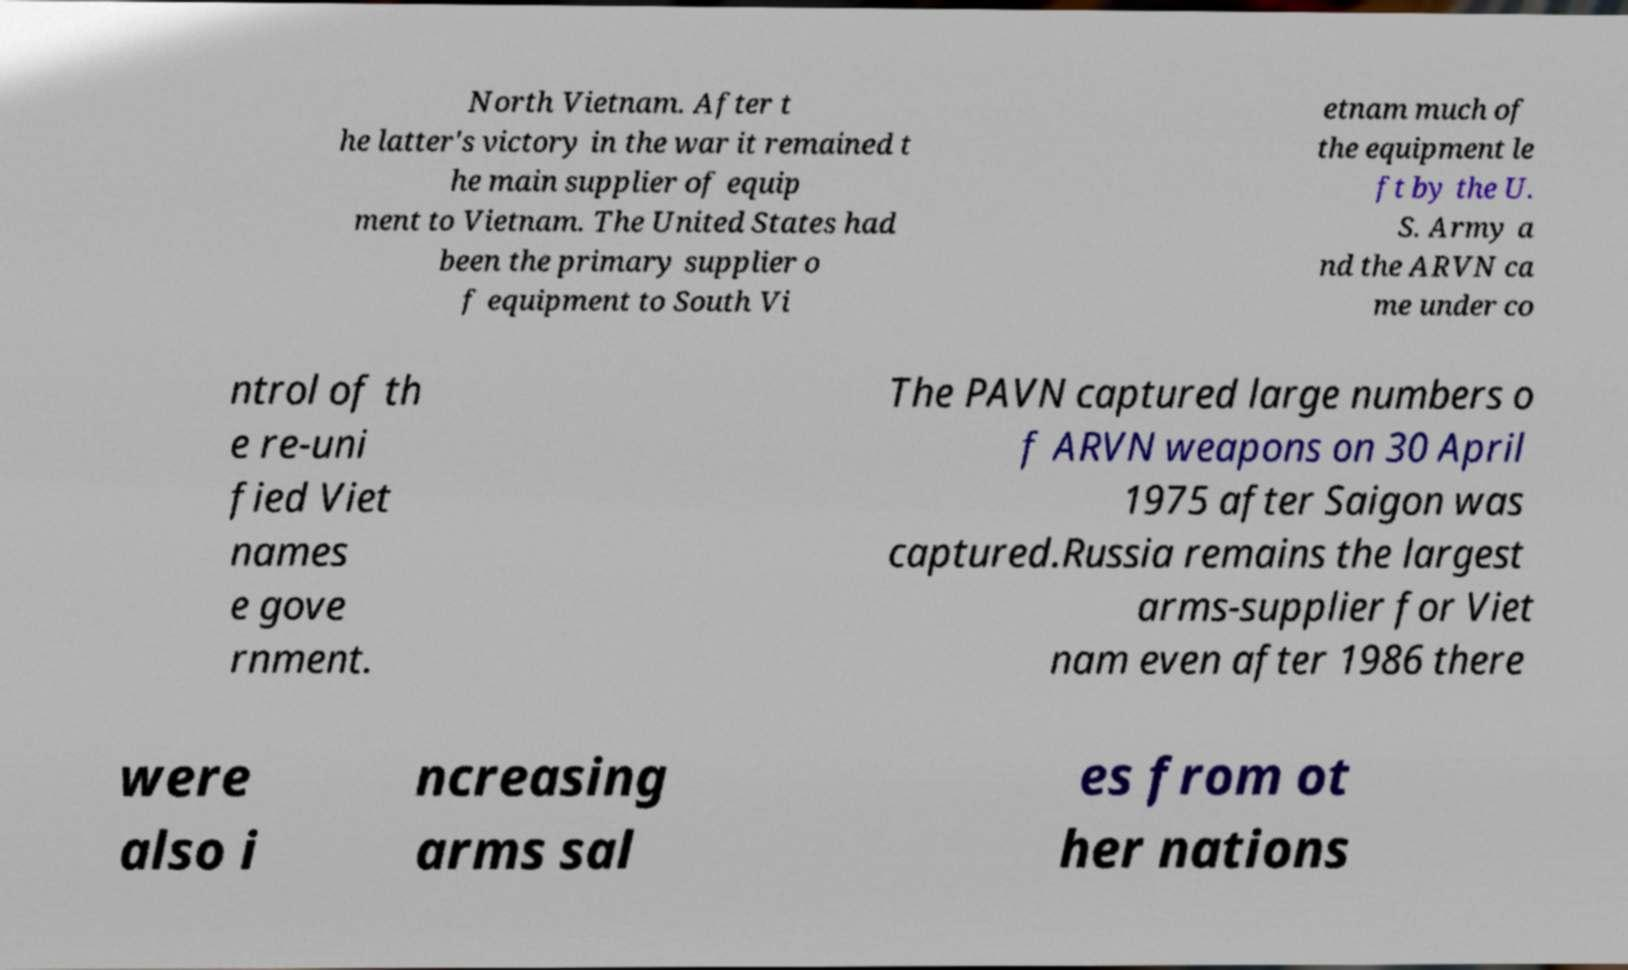I need the written content from this picture converted into text. Can you do that? North Vietnam. After t he latter's victory in the war it remained t he main supplier of equip ment to Vietnam. The United States had been the primary supplier o f equipment to South Vi etnam much of the equipment le ft by the U. S. Army a nd the ARVN ca me under co ntrol of th e re-uni fied Viet names e gove rnment. The PAVN captured large numbers o f ARVN weapons on 30 April 1975 after Saigon was captured.Russia remains the largest arms-supplier for Viet nam even after 1986 there were also i ncreasing arms sal es from ot her nations 